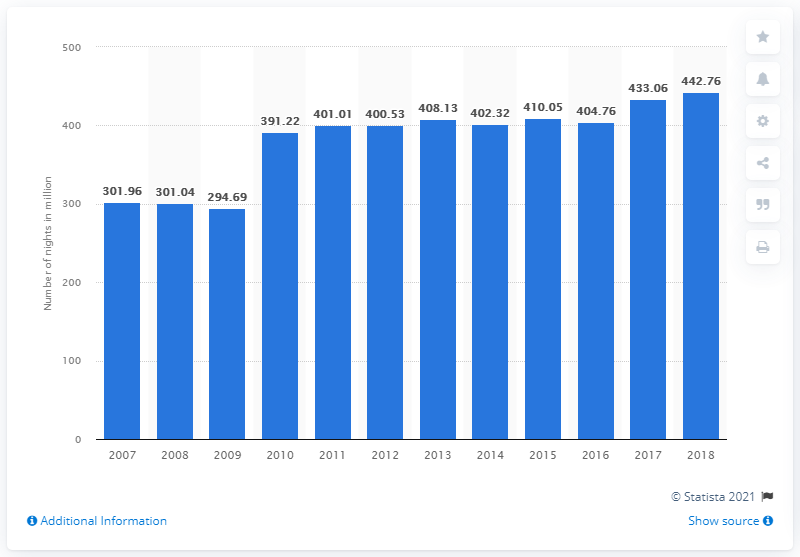Point out several critical features in this image. For the period of 2007 to 2018, a total of 442.76 nights were spent at tourist accommodation establishments in France. 